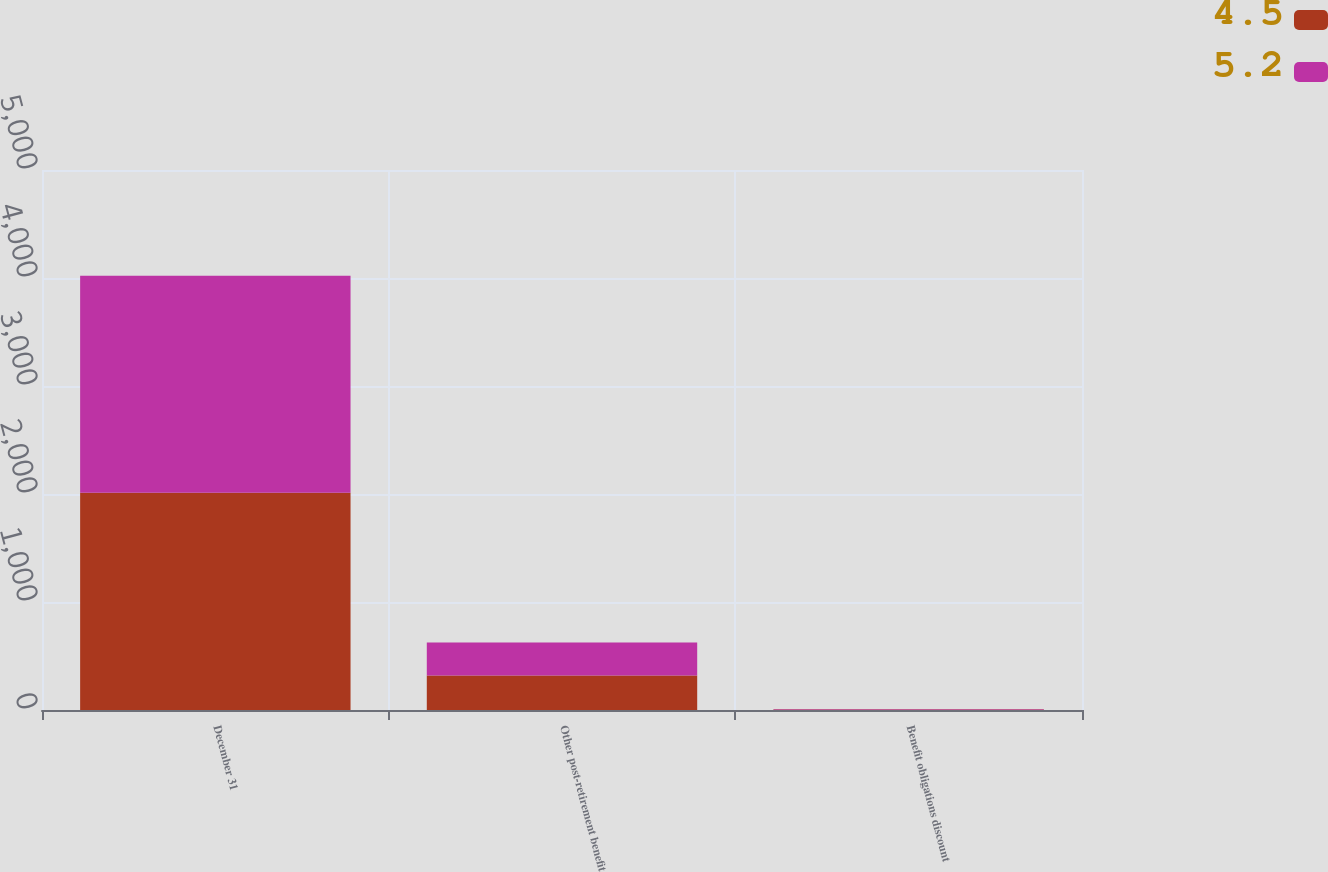<chart> <loc_0><loc_0><loc_500><loc_500><stacked_bar_chart><ecel><fcel>December 31<fcel>Other post-retirement benefit<fcel>Benefit obligations discount<nl><fcel>4.5<fcel>2011<fcel>318.5<fcel>4.5<nl><fcel>5.2<fcel>2010<fcel>306.3<fcel>5.2<nl></chart> 